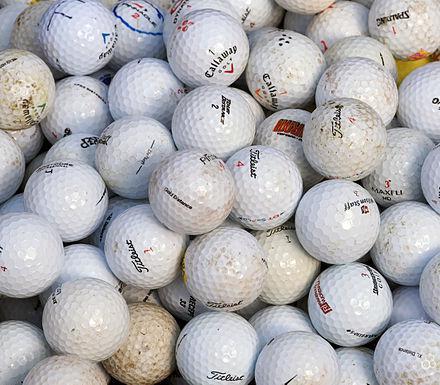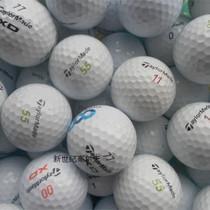The first image is the image on the left, the second image is the image on the right. For the images shown, is this caption "There is visible dirt on at least three golf balls." true? Answer yes or no. Yes. 